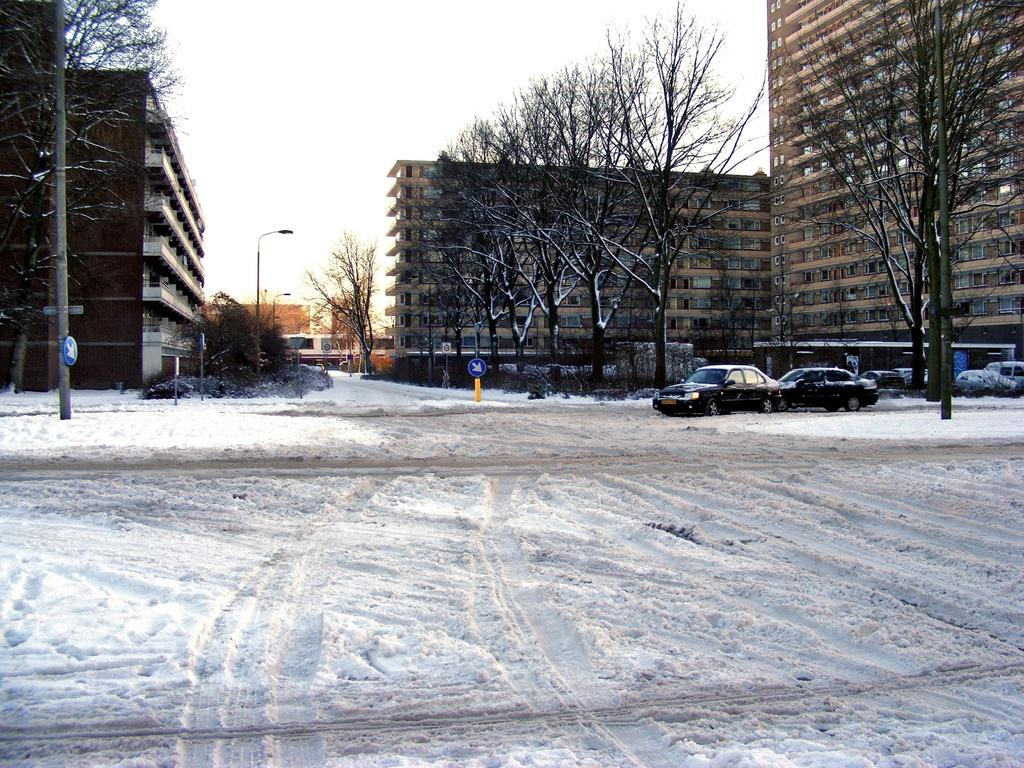What type of vehicles can be seen on the road in the image? There are vehicles on the snowy road in the image. What else can be seen in the image besides the vehicles? There are poles, trees, and buildings visible in the image. What type of produce is being harvested in the image? There is no produce visible in the image; it features vehicles on a snowy road with poles, trees, and buildings. 